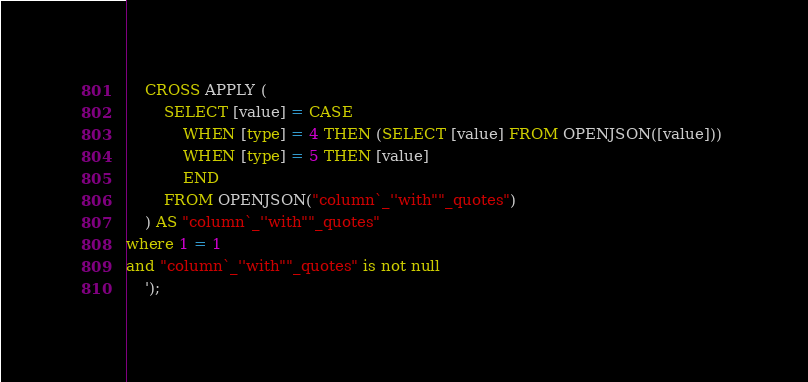Convert code to text. <code><loc_0><loc_0><loc_500><loc_500><_SQL_>
    CROSS APPLY (
	    SELECT [value] = CASE 
			WHEN [type] = 4 THEN (SELECT [value] FROM OPENJSON([value])) 
			WHEN [type] = 5 THEN [value]
			END
	    FROM OPENJSON("column`_''with""_quotes")
    ) AS "column`_''with""_quotes"
where 1 = 1
and "column`_''with""_quotes" is not null
    ');

</code> 